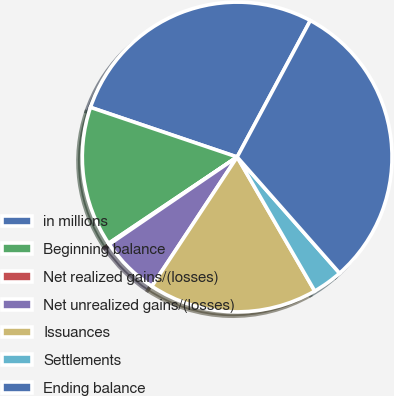<chart> <loc_0><loc_0><loc_500><loc_500><pie_chart><fcel>in millions<fcel>Beginning balance<fcel>Net realized gains/(losses)<fcel>Net unrealized gains/(losses)<fcel>Issuances<fcel>Settlements<fcel>Ending balance<nl><fcel>27.64%<fcel>14.61%<fcel>0.12%<fcel>6.18%<fcel>17.64%<fcel>3.15%<fcel>30.67%<nl></chart> 